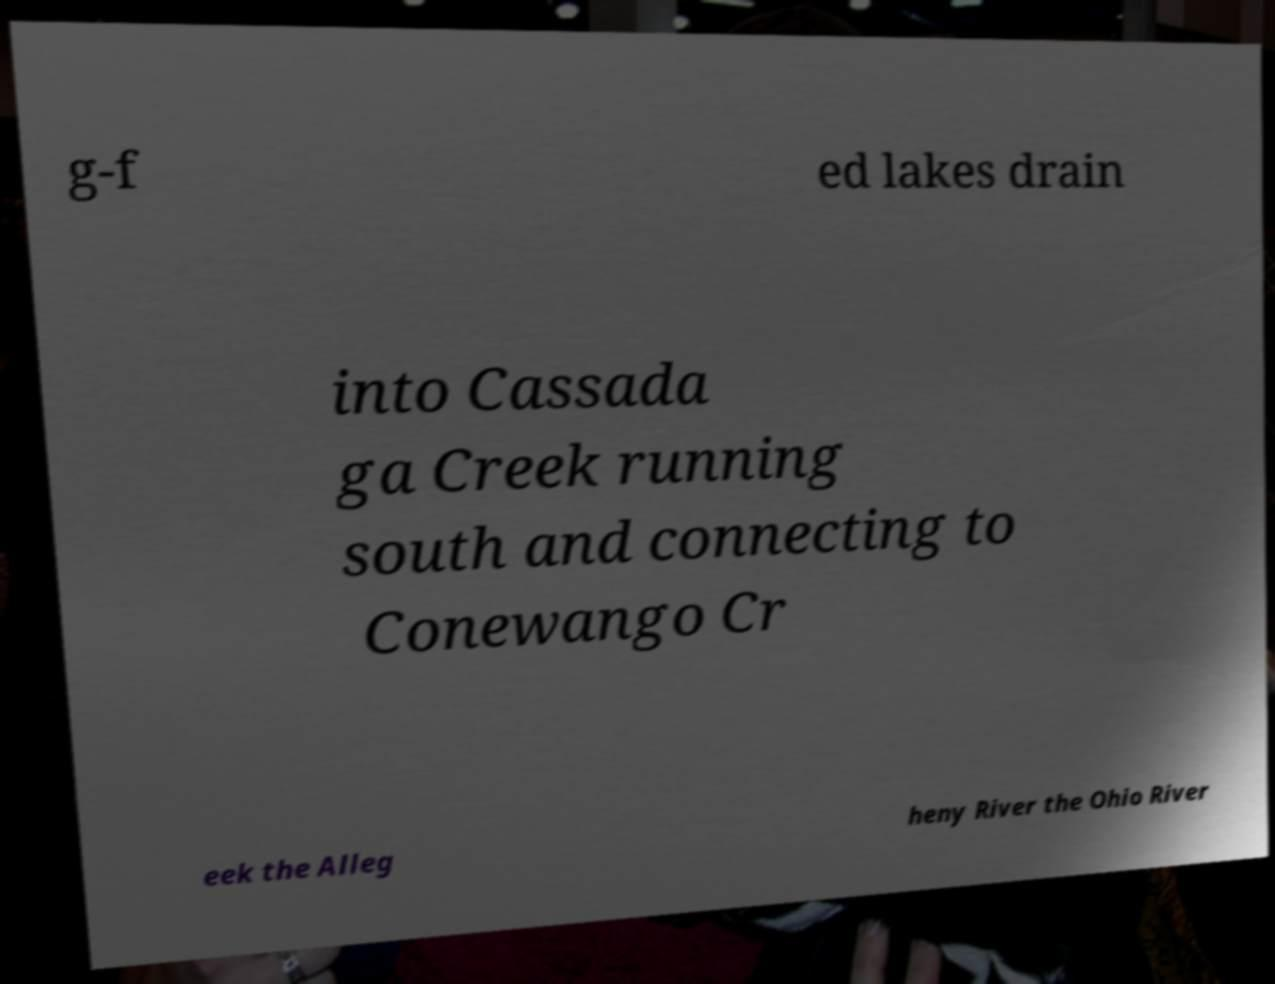For documentation purposes, I need the text within this image transcribed. Could you provide that? g-f ed lakes drain into Cassada ga Creek running south and connecting to Conewango Cr eek the Alleg heny River the Ohio River 